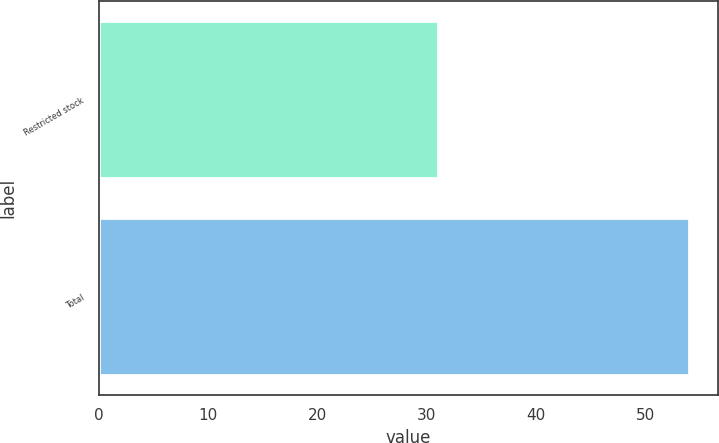Convert chart. <chart><loc_0><loc_0><loc_500><loc_500><bar_chart><fcel>Restricted stock<fcel>Total<nl><fcel>31<fcel>54<nl></chart> 